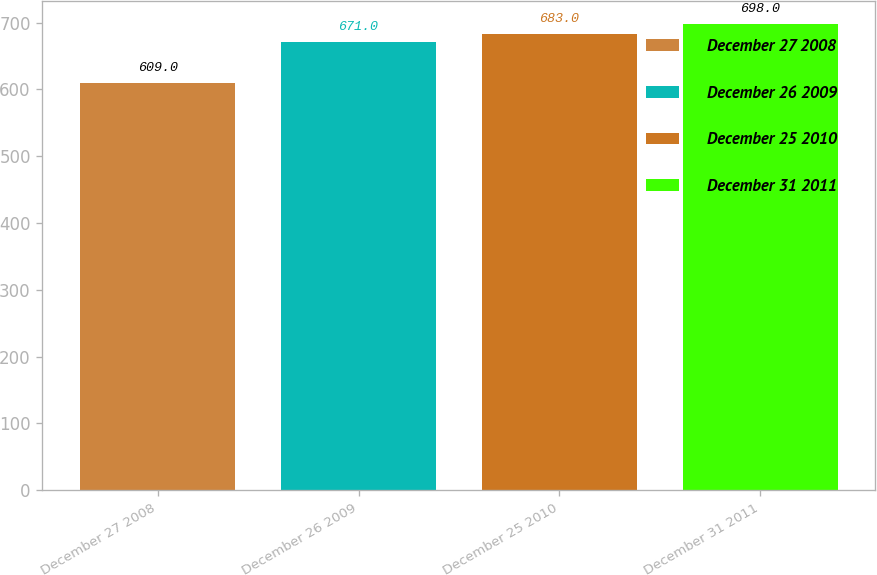<chart> <loc_0><loc_0><loc_500><loc_500><bar_chart><fcel>December 27 2008<fcel>December 26 2009<fcel>December 25 2010<fcel>December 31 2011<nl><fcel>609<fcel>671<fcel>683<fcel>698<nl></chart> 